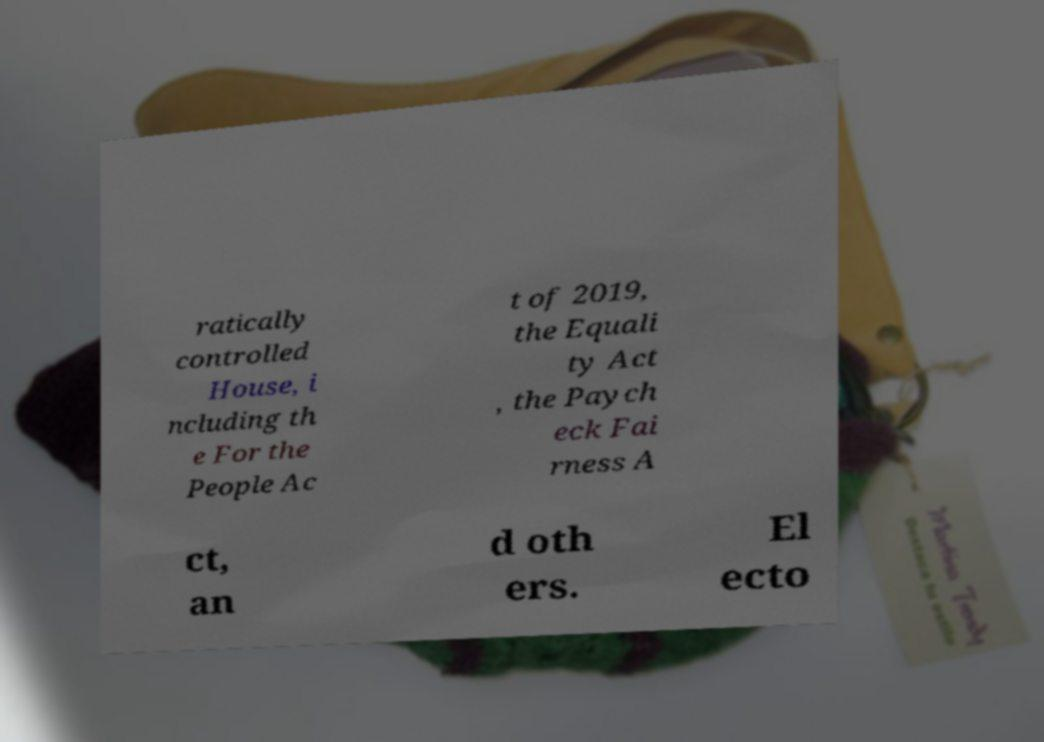Can you read and provide the text displayed in the image?This photo seems to have some interesting text. Can you extract and type it out for me? ratically controlled House, i ncluding th e For the People Ac t of 2019, the Equali ty Act , the Paych eck Fai rness A ct, an d oth ers. El ecto 